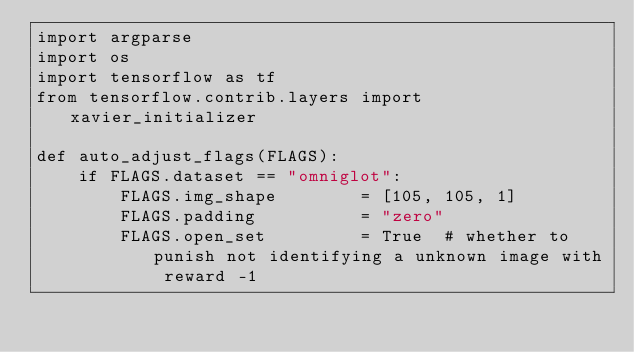<code> <loc_0><loc_0><loc_500><loc_500><_Python_>import argparse
import os
import tensorflow as tf
from tensorflow.contrib.layers import xavier_initializer

def auto_adjust_flags(FLAGS):
    if FLAGS.dataset == "omniglot":
        FLAGS.img_shape        = [105, 105, 1]
        FLAGS.padding          = "zero"
        FLAGS.open_set         = True  # whether to punish not identifying a unknown image with reward -1</code> 